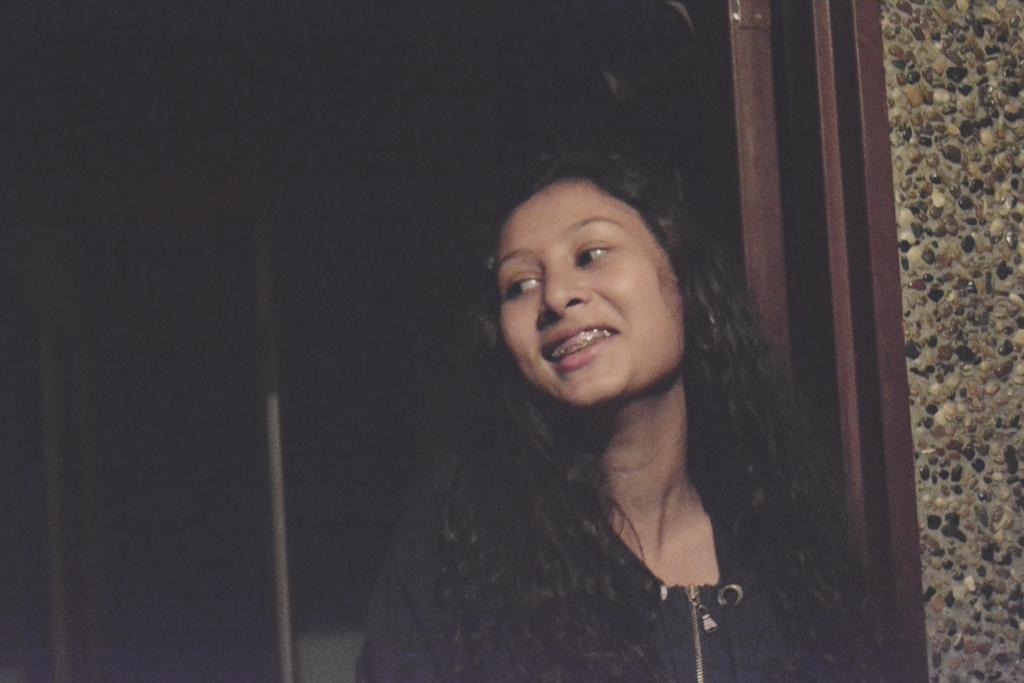Who is present in the image? There is a woman in the image. What expression does the woman have? The woman is smiling. What can be observed about the background of the image? The background of the image is dark. What type of nut is the woman holding in the image? There is no nut present in the image; the woman is not holding anything. 